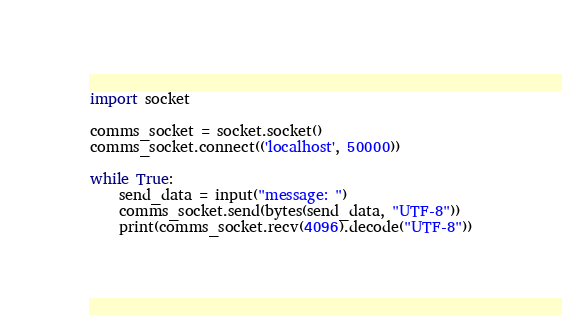Convert code to text. <code><loc_0><loc_0><loc_500><loc_500><_Python_>import socket

comms_socket = socket.socket()
comms_socket.connect(('localhost', 50000))

while True:
    send_data = input("message: ")
    comms_socket.send(bytes(send_data, "UTF-8"))
    print(comms_socket.recv(4096).decode("UTF-8"))
</code> 